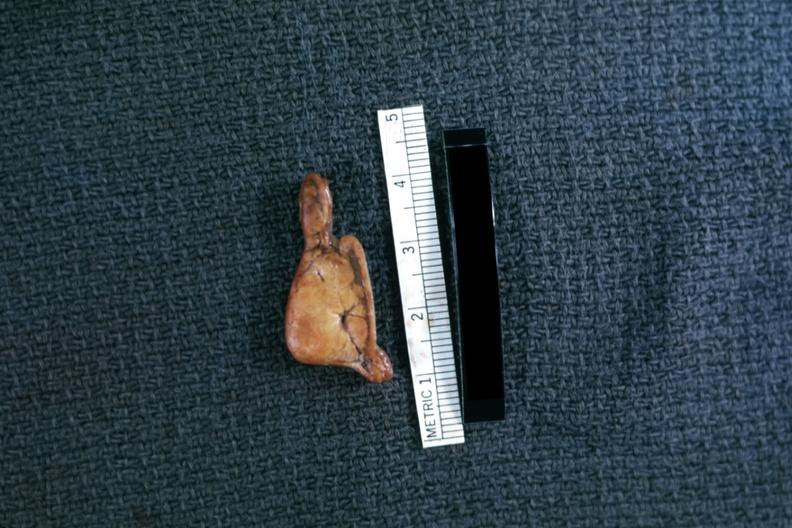where does this belong to?
Answer the question using a single word or phrase. Endocrine system 